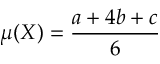Convert formula to latex. <formula><loc_0><loc_0><loc_500><loc_500>\mu ( X ) = { \frac { a + 4 b + c } { 6 } }</formula> 